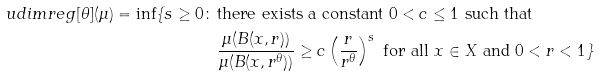Convert formula to latex. <formula><loc_0><loc_0><loc_500><loc_500>\ u d i m r e g [ \theta ] ( \mu ) = \inf \{ s \geq 0 \colon \, & \text {there exists a constant $0 < c \leq 1$ such that } \\ & \frac { \mu ( B ( x , r ) ) } { \mu ( B ( x , r ^ { \theta } ) ) } \geq c \left ( \frac { r } { r ^ { \theta } } \right ) ^ { s } \text { for all $x \in X$ and } 0 < r < 1 \}</formula> 